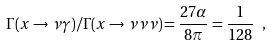Convert formula to latex. <formula><loc_0><loc_0><loc_500><loc_500>\Gamma ( x \to \nu \gamma ) / \Gamma ( x \to \nu \nu \nu ) = \frac { 2 7 \alpha } { 8 \pi } = { \frac { 1 } { 1 2 8 } } \ ,</formula> 